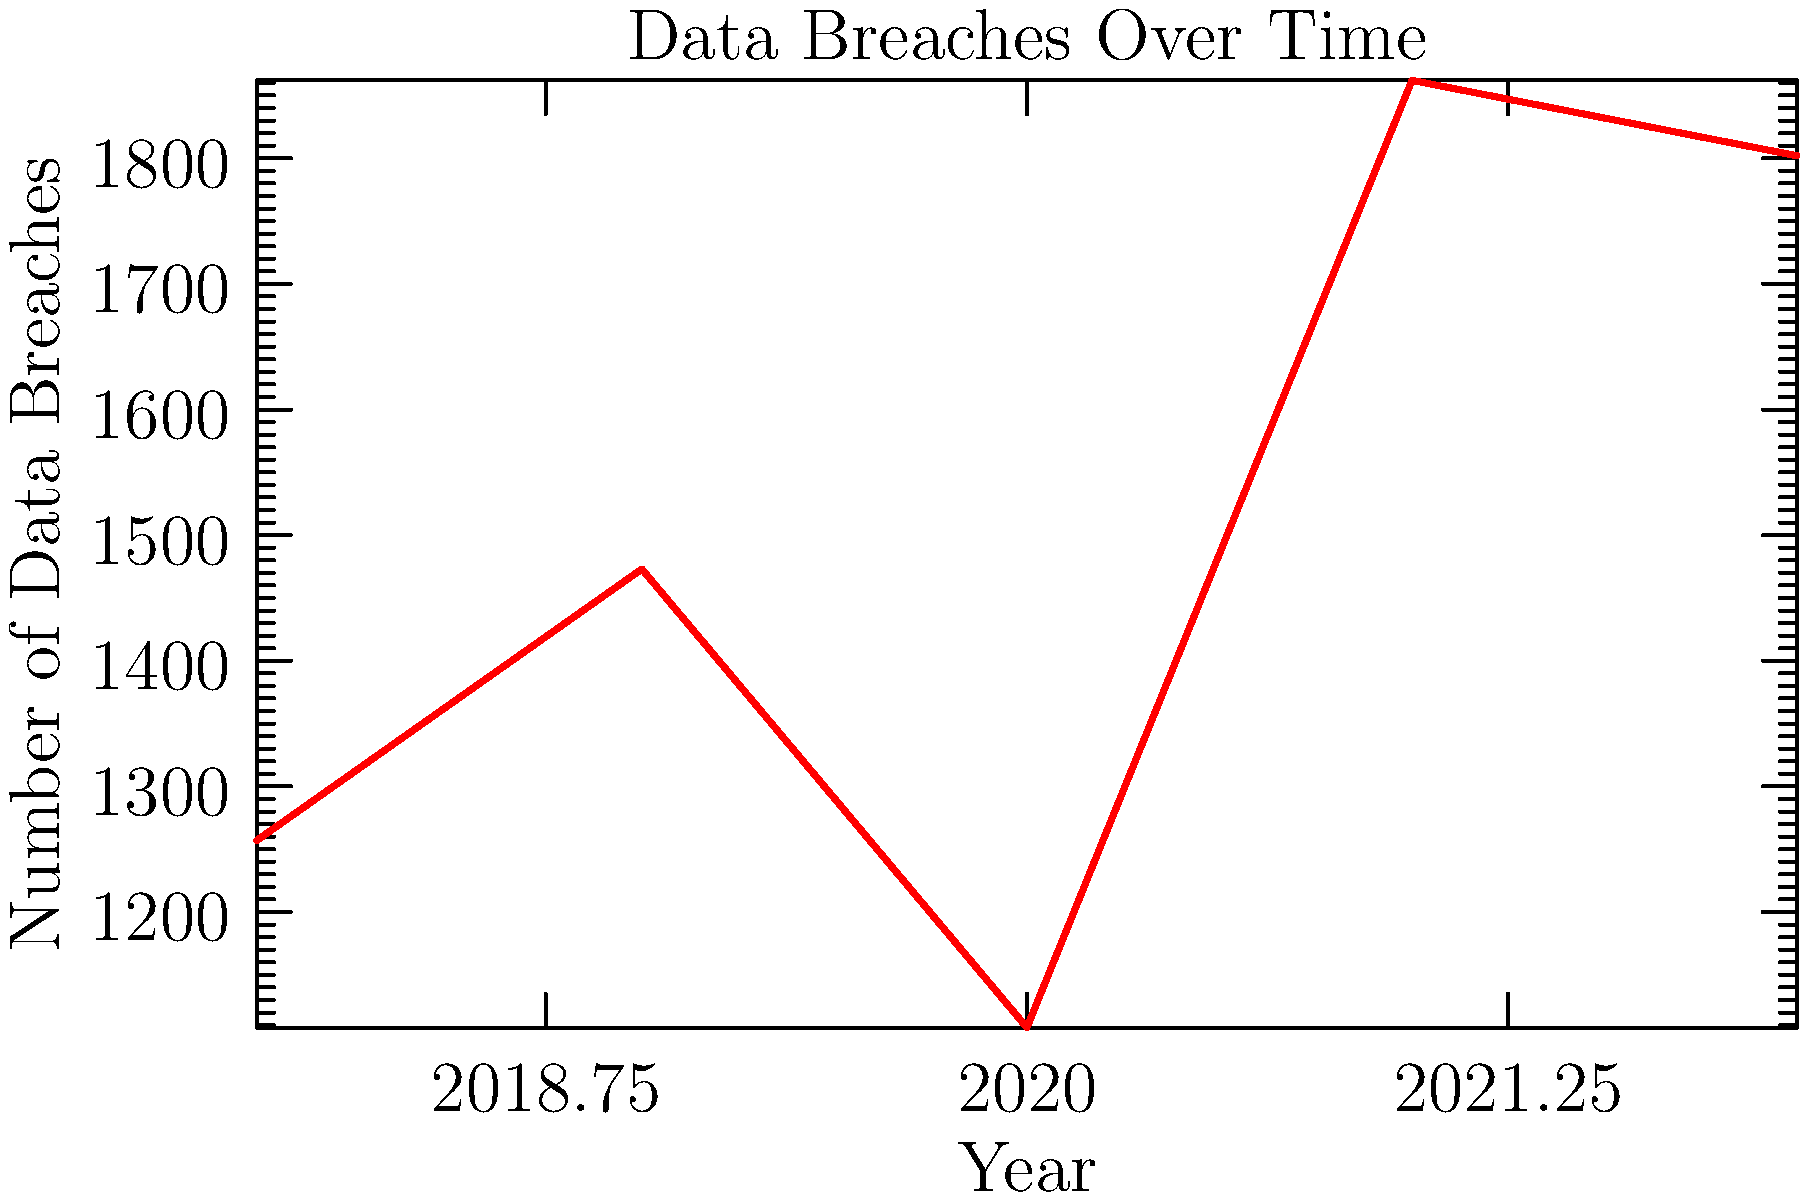As a newsroom leader, you're analyzing a report on data breaches over the past five years. The line graph shows the number of reported data breaches from 2018 to 2022. What year-over-year change would be most critical for a privacy-focused story, and why might this be significant for public awareness? To answer this question, let's analyze the data breach trends year by year:

1. 2018 to 2019: Increase from 1257 to 1473 breaches (+216)
2. 2019 to 2020: Decrease from 1473 to 1108 breaches (-365)
3. 2020 to 2021: Sharp increase from 1108 to 1862 breaches (+754)
4. 2021 to 2022: Slight decrease from 1862 to 1802 breaches (-60)

The most critical year-over-year change is the sharp increase from 2020 to 2021 (+754 breaches). This is significant because:

1. It's the largest change in absolute numbers.
2. It represents a 68% increase in just one year.
3. It occurred during a time of increased reliance on digital technologies due to the COVID-19 pandemic.
4. It could indicate a surge in cybercriminal activity or vulnerabilities in rapidly adopted remote working systems.

This change would be most critical for a privacy-focused story as it highlights a sudden and dramatic increase in data breach incidents, potentially affecting millions of people's personal information. It raises questions about the causes behind this surge and the preparedness of organizations to protect sensitive data in a rapidly changing digital landscape.
Answer: The 2020 to 2021 increase (+754 breaches), due to its magnitude and timing during increased digital reliance. 